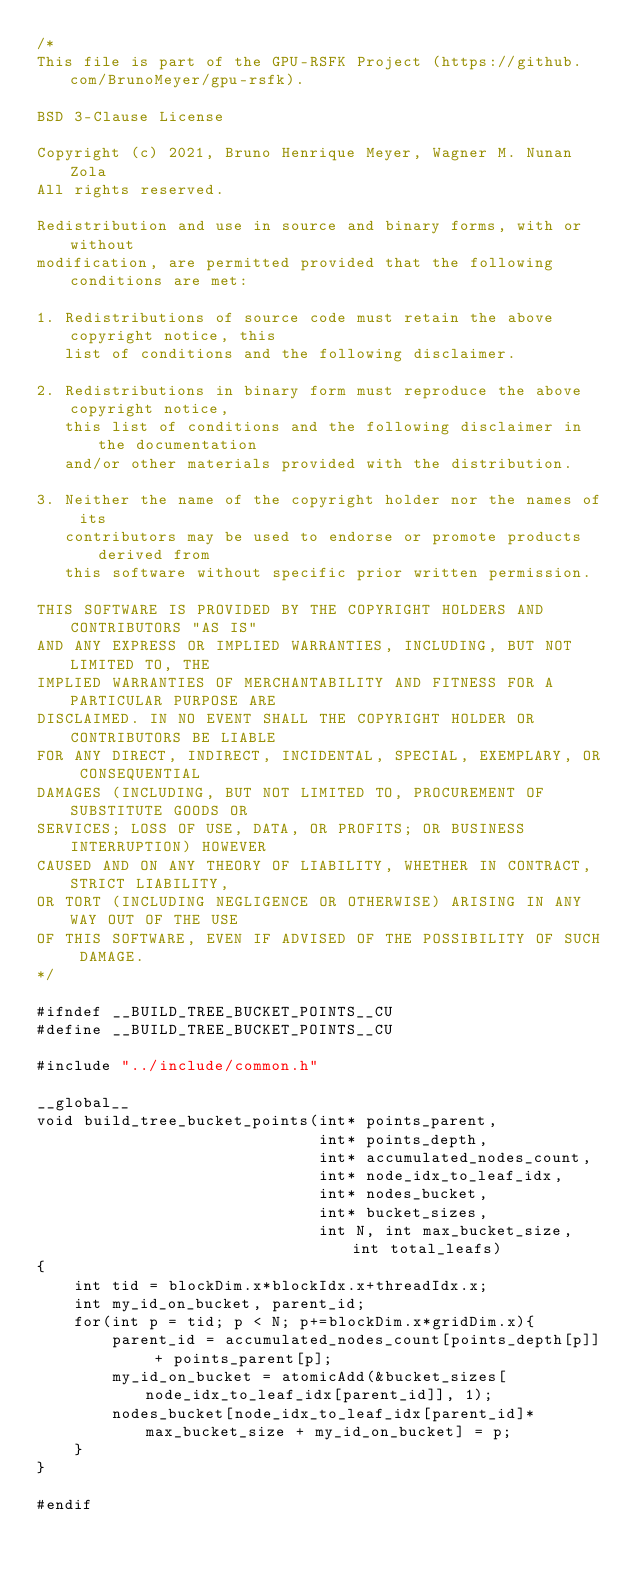<code> <loc_0><loc_0><loc_500><loc_500><_Cuda_>/*
This file is part of the GPU-RSFK Project (https://github.com/BrunoMeyer/gpu-rsfk).

BSD 3-Clause License

Copyright (c) 2021, Bruno Henrique Meyer, Wagner M. Nunan Zola
All rights reserved.

Redistribution and use in source and binary forms, with or without
modification, are permitted provided that the following conditions are met:

1. Redistributions of source code must retain the above copyright notice, this
   list of conditions and the following disclaimer.

2. Redistributions in binary form must reproduce the above copyright notice,
   this list of conditions and the following disclaimer in the documentation
   and/or other materials provided with the distribution.

3. Neither the name of the copyright holder nor the names of its
   contributors may be used to endorse or promote products derived from
   this software without specific prior written permission.

THIS SOFTWARE IS PROVIDED BY THE COPYRIGHT HOLDERS AND CONTRIBUTORS "AS IS"
AND ANY EXPRESS OR IMPLIED WARRANTIES, INCLUDING, BUT NOT LIMITED TO, THE
IMPLIED WARRANTIES OF MERCHANTABILITY AND FITNESS FOR A PARTICULAR PURPOSE ARE
DISCLAIMED. IN NO EVENT SHALL THE COPYRIGHT HOLDER OR CONTRIBUTORS BE LIABLE
FOR ANY DIRECT, INDIRECT, INCIDENTAL, SPECIAL, EXEMPLARY, OR CONSEQUENTIAL
DAMAGES (INCLUDING, BUT NOT LIMITED TO, PROCUREMENT OF SUBSTITUTE GOODS OR
SERVICES; LOSS OF USE, DATA, OR PROFITS; OR BUSINESS INTERRUPTION) HOWEVER
CAUSED AND ON ANY THEORY OF LIABILITY, WHETHER IN CONTRACT, STRICT LIABILITY,
OR TORT (INCLUDING NEGLIGENCE OR OTHERWISE) ARISING IN ANY WAY OUT OF THE USE
OF THIS SOFTWARE, EVEN IF ADVISED OF THE POSSIBILITY OF SUCH DAMAGE.
*/

#ifndef __BUILD_TREE_BUCKET_POINTS__CU
#define __BUILD_TREE_BUCKET_POINTS__CU

#include "../include/common.h"

__global__
void build_tree_bucket_points(int* points_parent,
                              int* points_depth,
                              int* accumulated_nodes_count,
                              int* node_idx_to_leaf_idx,
                              int* nodes_bucket,
                              int* bucket_sizes,
                              int N, int max_bucket_size, int total_leafs)
{
    int tid = blockDim.x*blockIdx.x+threadIdx.x;
    int my_id_on_bucket, parent_id;
    for(int p = tid; p < N; p+=blockDim.x*gridDim.x){
        parent_id = accumulated_nodes_count[points_depth[p]] + points_parent[p];
        my_id_on_bucket = atomicAdd(&bucket_sizes[node_idx_to_leaf_idx[parent_id]], 1);
        nodes_bucket[node_idx_to_leaf_idx[parent_id]*max_bucket_size + my_id_on_bucket] = p;
    }
}

#endif</code> 